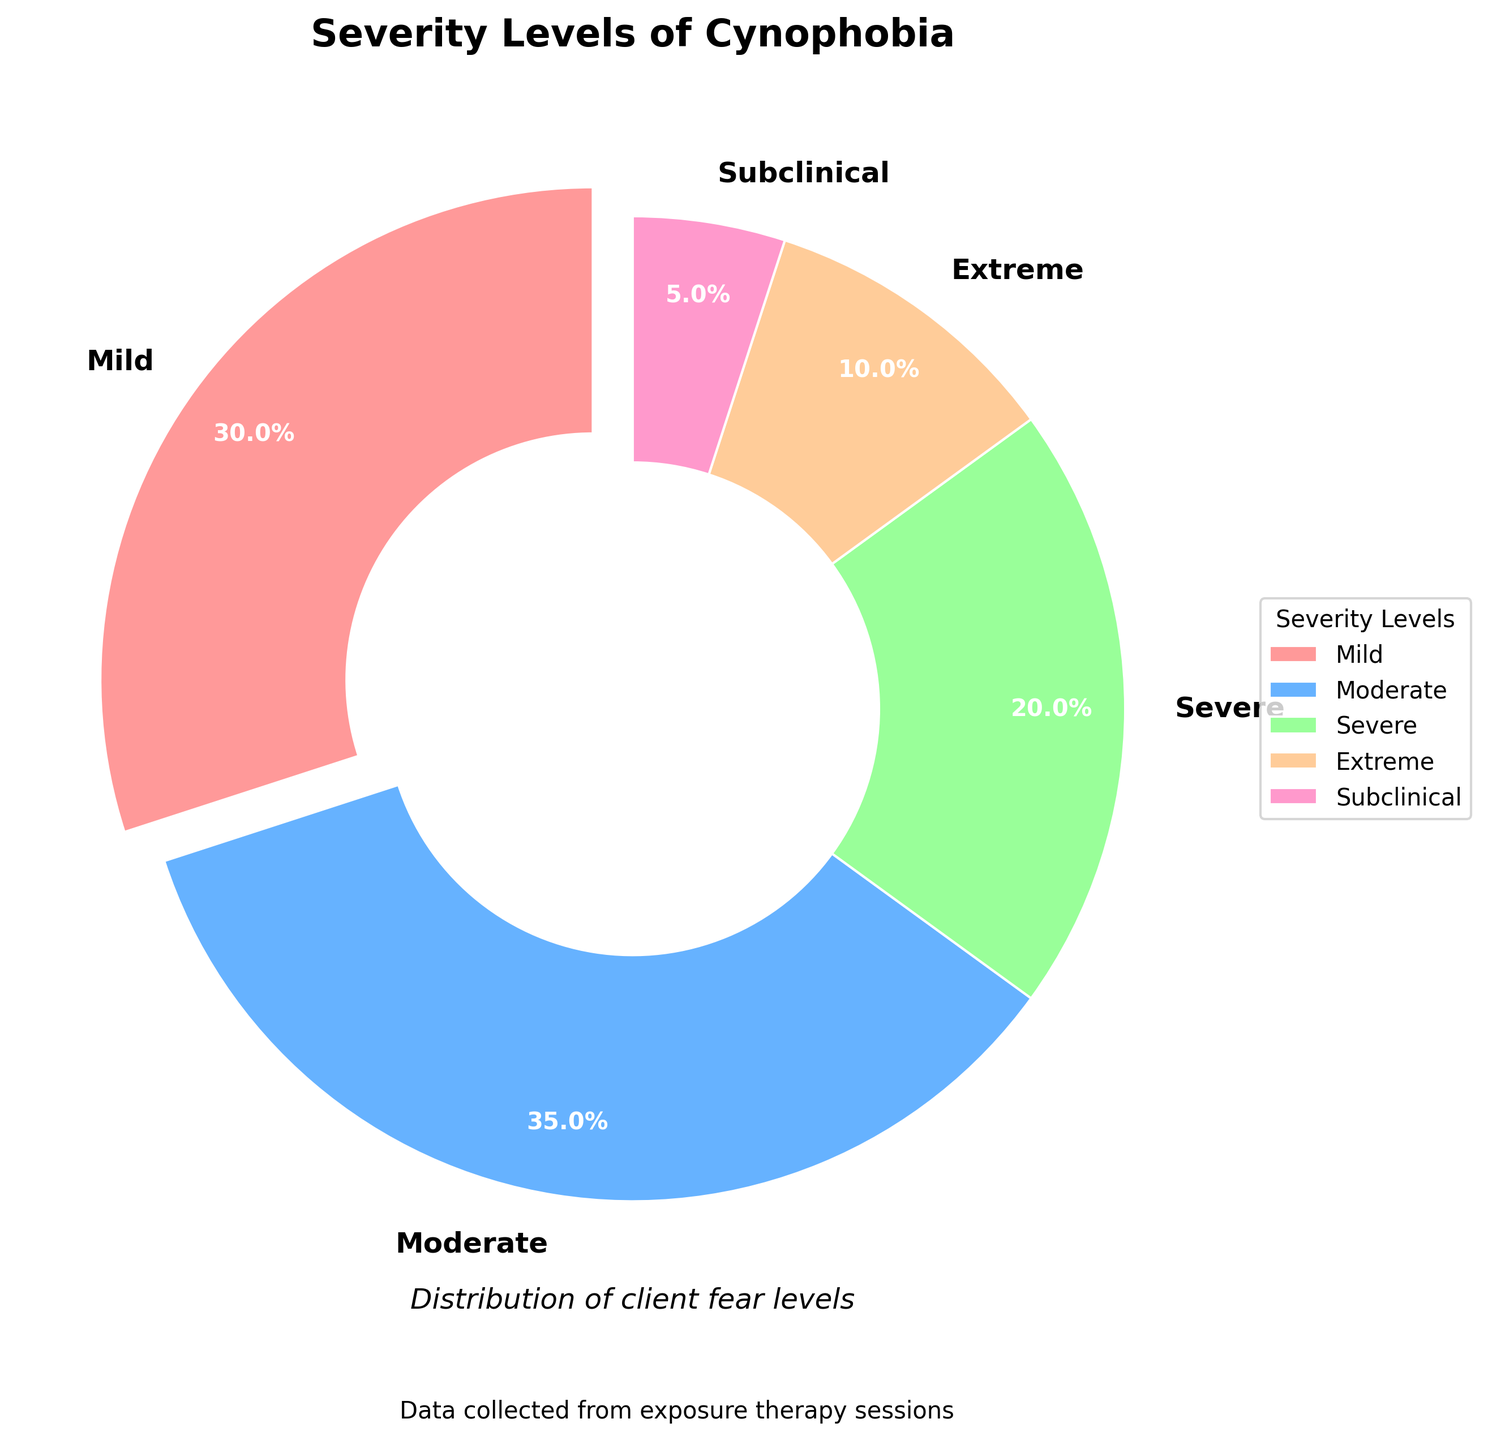What's the most common severity level of cynophobia among clients? Look at the pie chart and find the segment with the largest percentage. The "Moderate" segment has the largest percentage at 35%.
Answer: Moderate Which two severity levels together account for more than half of the clients? The "Mild" level is 30% and "Moderate" level is 35%. Adding these two percentages, 30% + 35% = 65%, which is more than half.
Answer: Mild and Moderate How much higher is the percentage of clients with Mild cynophobia compared to Extreme cynophobia? The percentage for Mild is 30% and for Extreme is 10%. Subtract the smaller percentage from the larger one: 30% - 10% = 20%.
Answer: 20% Which severity level has the smallest percentage of clients, and what is that percentage? Refer to the pie chart and find the smallest segment. It corresponds to "Subclinical" with a percentage of 5%.
Answer: Subclinical, 5% Among Severe and Extreme levels, which one has a higher percentage and by how much? Look at the pie chart to compare the percentages: Severe is 20% and Extreme is 10%. The difference is 20% - 10% = 10%.
Answer: Severe, 10% What is the total percentage of clients with Severe or worse cynophobia (Severe + Extreme)? Sum the percentages of Severe (20%) and Extreme (10%): 20% + 10% = 30%.
Answer: 30% Which severity level is represented by the pink segment in the pie chart? You can identify the color by referring to the pie chart. In this chart, the Mild severity level is represented by pink.
Answer: Mild How does the sum of clients with Subclinical and Extreme cynophobia compare to those with Moderate cynophobia alone? Add the percentages of Subclinical (5%) and Extreme (10%): 5% + 10% = 15%. Compare this to Moderate: 35%. Therefore, 15% is less than 35%.
Answer: Less What is the difference in the percentage of clients with Moderate compared to Severe cynophobia? The percentage of clients with Moderate cynophobia is 35%, and for Severe it is 20%. Subtract the smaller percentage from the larger one: 35% - 20% = 15%.
Answer: 15% Look at the pie chart and identify the severity level with a light blue color. What percentage of clients does it represent? Identify the light blue segment in the pie chart which corresponds to the "Moderate" severity level. It represents 35% of the clients.
Answer: Moderate, 35% 